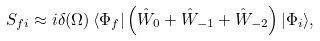<formula> <loc_0><loc_0><loc_500><loc_500>S _ { f i } \approx i \delta ( \Omega ) \, \langle \Phi _ { f } | \left ( \hat { W } _ { 0 } + \hat { W } _ { - 1 } + \hat { W } _ { - 2 } \right ) | \Phi _ { i } \rangle ,</formula> 